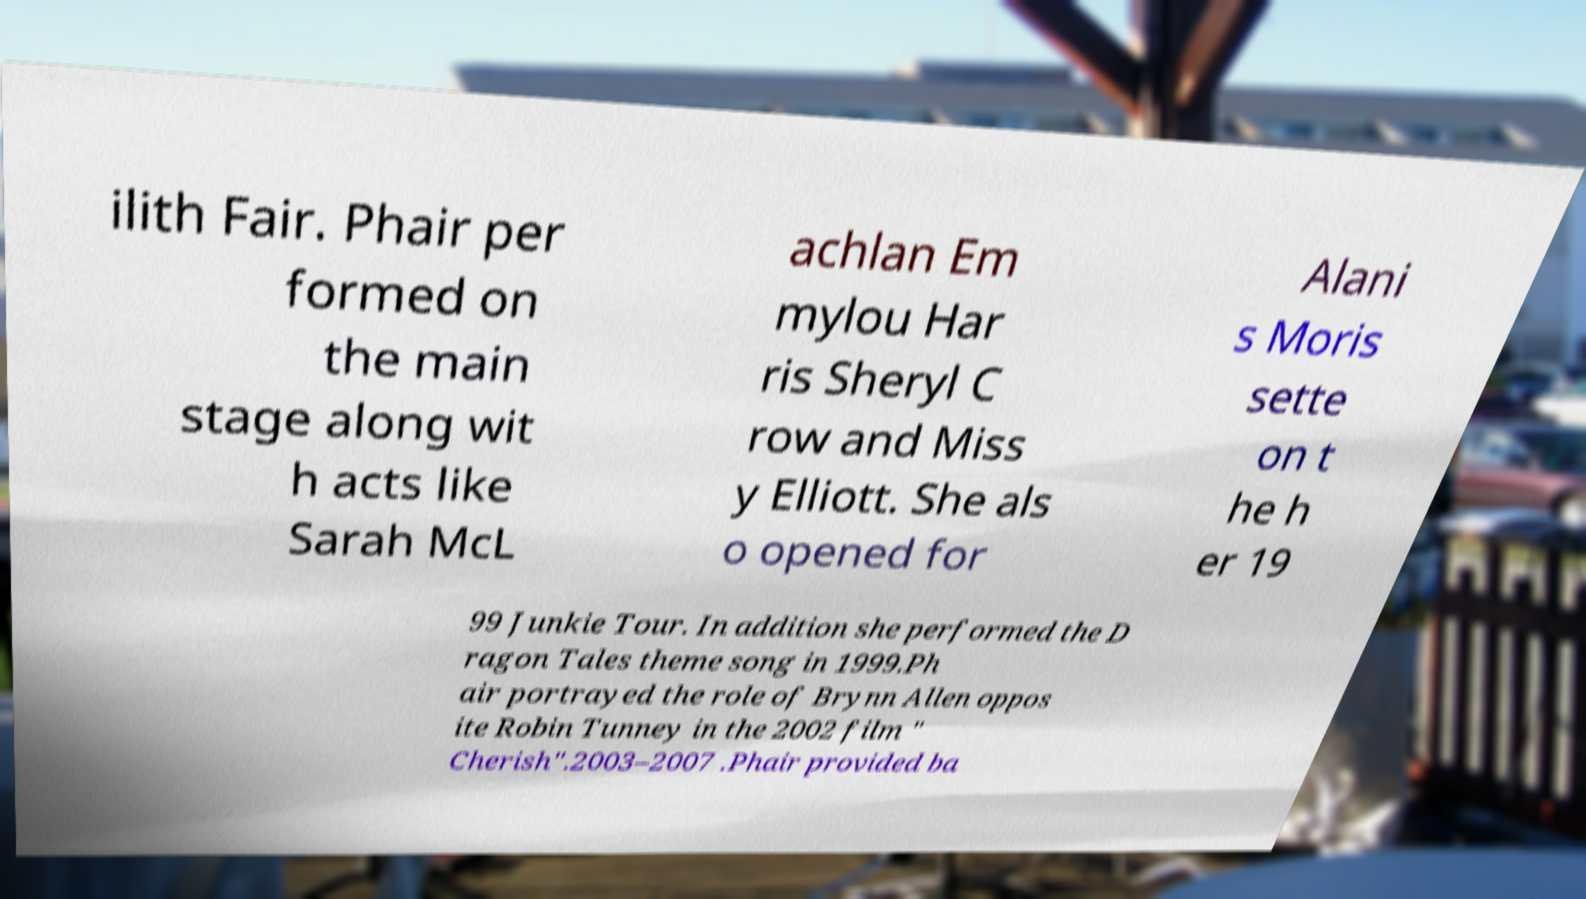Can you read and provide the text displayed in the image?This photo seems to have some interesting text. Can you extract and type it out for me? ilith Fair. Phair per formed on the main stage along wit h acts like Sarah McL achlan Em mylou Har ris Sheryl C row and Miss y Elliott. She als o opened for Alani s Moris sette on t he h er 19 99 Junkie Tour. In addition she performed the D ragon Tales theme song in 1999.Ph air portrayed the role of Brynn Allen oppos ite Robin Tunney in the 2002 film " Cherish".2003–2007 .Phair provided ba 